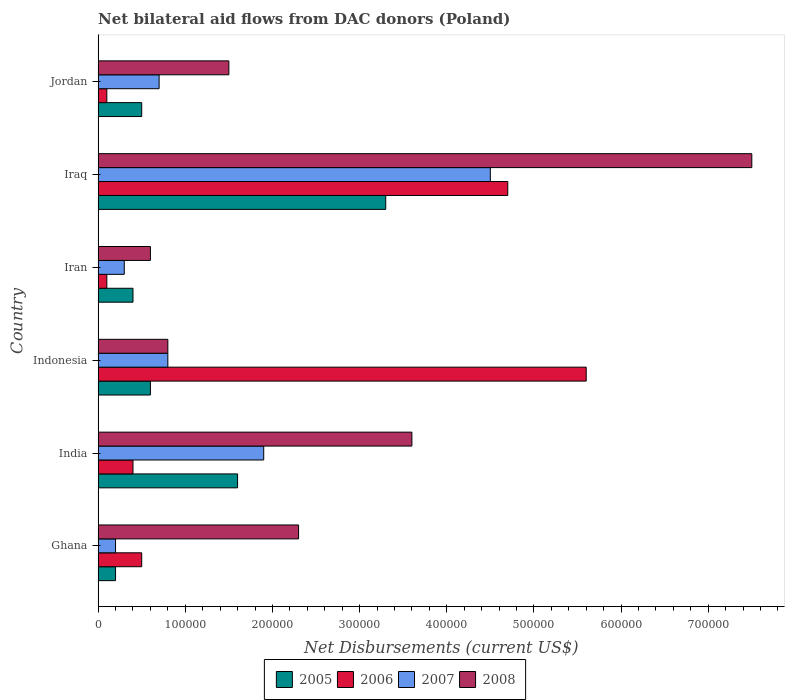How many groups of bars are there?
Provide a short and direct response. 6. Are the number of bars on each tick of the Y-axis equal?
Keep it short and to the point. Yes. What is the label of the 6th group of bars from the top?
Ensure brevity in your answer.  Ghana. Across all countries, what is the maximum net bilateral aid flows in 2006?
Offer a very short reply. 5.60e+05. Across all countries, what is the minimum net bilateral aid flows in 2008?
Your answer should be very brief. 6.00e+04. In which country was the net bilateral aid flows in 2008 maximum?
Your response must be concise. Iraq. In which country was the net bilateral aid flows in 2006 minimum?
Provide a short and direct response. Iran. What is the total net bilateral aid flows in 2006 in the graph?
Your answer should be compact. 1.14e+06. What is the difference between the net bilateral aid flows in 2005 in Indonesia and that in Iraq?
Give a very brief answer. -2.70e+05. What is the average net bilateral aid flows in 2006 per country?
Keep it short and to the point. 1.90e+05. What is the ratio of the net bilateral aid flows in 2007 in Indonesia to that in Iran?
Your answer should be very brief. 2.67. Is the net bilateral aid flows in 2006 in Iran less than that in Jordan?
Make the answer very short. No. Is the difference between the net bilateral aid flows in 2008 in Ghana and Iraq greater than the difference between the net bilateral aid flows in 2005 in Ghana and Iraq?
Provide a succinct answer. No. In how many countries, is the net bilateral aid flows in 2006 greater than the average net bilateral aid flows in 2006 taken over all countries?
Ensure brevity in your answer.  2. Is the sum of the net bilateral aid flows in 2008 in India and Indonesia greater than the maximum net bilateral aid flows in 2007 across all countries?
Give a very brief answer. No. Is it the case that in every country, the sum of the net bilateral aid flows in 2008 and net bilateral aid flows in 2007 is greater than the sum of net bilateral aid flows in 2006 and net bilateral aid flows in 2005?
Offer a very short reply. No. What does the 1st bar from the top in Jordan represents?
Provide a short and direct response. 2008. How many bars are there?
Your answer should be compact. 24. What is the difference between two consecutive major ticks on the X-axis?
Your answer should be very brief. 1.00e+05. Are the values on the major ticks of X-axis written in scientific E-notation?
Offer a terse response. No. Does the graph contain any zero values?
Make the answer very short. No. Does the graph contain grids?
Your answer should be very brief. No. What is the title of the graph?
Offer a terse response. Net bilateral aid flows from DAC donors (Poland). Does "1983" appear as one of the legend labels in the graph?
Ensure brevity in your answer.  No. What is the label or title of the X-axis?
Your answer should be very brief. Net Disbursements (current US$). What is the Net Disbursements (current US$) of 2007 in Ghana?
Your answer should be very brief. 2.00e+04. What is the Net Disbursements (current US$) of 2008 in Ghana?
Ensure brevity in your answer.  2.30e+05. What is the Net Disbursements (current US$) in 2005 in India?
Provide a short and direct response. 1.60e+05. What is the Net Disbursements (current US$) of 2008 in India?
Make the answer very short. 3.60e+05. What is the Net Disbursements (current US$) in 2006 in Indonesia?
Provide a short and direct response. 5.60e+05. What is the Net Disbursements (current US$) of 2008 in Indonesia?
Your response must be concise. 8.00e+04. What is the Net Disbursements (current US$) in 2006 in Iran?
Offer a terse response. 10000. What is the Net Disbursements (current US$) of 2008 in Iran?
Make the answer very short. 6.00e+04. What is the Net Disbursements (current US$) in 2008 in Iraq?
Provide a short and direct response. 7.50e+05. What is the Net Disbursements (current US$) of 2005 in Jordan?
Offer a very short reply. 5.00e+04. What is the Net Disbursements (current US$) in 2007 in Jordan?
Your response must be concise. 7.00e+04. What is the Net Disbursements (current US$) of 2008 in Jordan?
Give a very brief answer. 1.50e+05. Across all countries, what is the maximum Net Disbursements (current US$) of 2006?
Keep it short and to the point. 5.60e+05. Across all countries, what is the maximum Net Disbursements (current US$) of 2007?
Your answer should be compact. 4.50e+05. Across all countries, what is the maximum Net Disbursements (current US$) of 2008?
Provide a succinct answer. 7.50e+05. Across all countries, what is the minimum Net Disbursements (current US$) in 2005?
Make the answer very short. 2.00e+04. What is the total Net Disbursements (current US$) of 2006 in the graph?
Offer a very short reply. 1.14e+06. What is the total Net Disbursements (current US$) of 2007 in the graph?
Your answer should be compact. 8.40e+05. What is the total Net Disbursements (current US$) in 2008 in the graph?
Provide a succinct answer. 1.63e+06. What is the difference between the Net Disbursements (current US$) in 2005 in Ghana and that in India?
Provide a succinct answer. -1.40e+05. What is the difference between the Net Disbursements (current US$) in 2006 in Ghana and that in India?
Provide a succinct answer. 10000. What is the difference between the Net Disbursements (current US$) in 2006 in Ghana and that in Indonesia?
Ensure brevity in your answer.  -5.10e+05. What is the difference between the Net Disbursements (current US$) of 2008 in Ghana and that in Indonesia?
Make the answer very short. 1.50e+05. What is the difference between the Net Disbursements (current US$) of 2006 in Ghana and that in Iran?
Your answer should be compact. 4.00e+04. What is the difference between the Net Disbursements (current US$) of 2007 in Ghana and that in Iran?
Keep it short and to the point. -10000. What is the difference between the Net Disbursements (current US$) in 2008 in Ghana and that in Iran?
Keep it short and to the point. 1.70e+05. What is the difference between the Net Disbursements (current US$) in 2005 in Ghana and that in Iraq?
Your answer should be compact. -3.10e+05. What is the difference between the Net Disbursements (current US$) in 2006 in Ghana and that in Iraq?
Make the answer very short. -4.20e+05. What is the difference between the Net Disbursements (current US$) in 2007 in Ghana and that in Iraq?
Your answer should be very brief. -4.30e+05. What is the difference between the Net Disbursements (current US$) of 2008 in Ghana and that in Iraq?
Provide a short and direct response. -5.20e+05. What is the difference between the Net Disbursements (current US$) in 2007 in Ghana and that in Jordan?
Offer a very short reply. -5.00e+04. What is the difference between the Net Disbursements (current US$) in 2008 in Ghana and that in Jordan?
Provide a short and direct response. 8.00e+04. What is the difference between the Net Disbursements (current US$) in 2005 in India and that in Indonesia?
Offer a very short reply. 1.00e+05. What is the difference between the Net Disbursements (current US$) in 2006 in India and that in Indonesia?
Offer a terse response. -5.20e+05. What is the difference between the Net Disbursements (current US$) of 2007 in India and that in Indonesia?
Make the answer very short. 1.10e+05. What is the difference between the Net Disbursements (current US$) in 2008 in India and that in Indonesia?
Give a very brief answer. 2.80e+05. What is the difference between the Net Disbursements (current US$) of 2006 in India and that in Iran?
Offer a terse response. 3.00e+04. What is the difference between the Net Disbursements (current US$) in 2007 in India and that in Iran?
Ensure brevity in your answer.  1.60e+05. What is the difference between the Net Disbursements (current US$) of 2005 in India and that in Iraq?
Your answer should be compact. -1.70e+05. What is the difference between the Net Disbursements (current US$) in 2006 in India and that in Iraq?
Your response must be concise. -4.30e+05. What is the difference between the Net Disbursements (current US$) in 2008 in India and that in Iraq?
Your answer should be very brief. -3.90e+05. What is the difference between the Net Disbursements (current US$) in 2007 in India and that in Jordan?
Provide a succinct answer. 1.20e+05. What is the difference between the Net Disbursements (current US$) in 2008 in India and that in Jordan?
Your response must be concise. 2.10e+05. What is the difference between the Net Disbursements (current US$) in 2007 in Indonesia and that in Iran?
Offer a terse response. 5.00e+04. What is the difference between the Net Disbursements (current US$) of 2008 in Indonesia and that in Iran?
Provide a succinct answer. 2.00e+04. What is the difference between the Net Disbursements (current US$) of 2007 in Indonesia and that in Iraq?
Provide a succinct answer. -3.70e+05. What is the difference between the Net Disbursements (current US$) of 2008 in Indonesia and that in Iraq?
Keep it short and to the point. -6.70e+05. What is the difference between the Net Disbursements (current US$) of 2005 in Indonesia and that in Jordan?
Offer a terse response. 10000. What is the difference between the Net Disbursements (current US$) of 2007 in Indonesia and that in Jordan?
Your answer should be compact. 10000. What is the difference between the Net Disbursements (current US$) of 2006 in Iran and that in Iraq?
Keep it short and to the point. -4.60e+05. What is the difference between the Net Disbursements (current US$) in 2007 in Iran and that in Iraq?
Your response must be concise. -4.20e+05. What is the difference between the Net Disbursements (current US$) in 2008 in Iran and that in Iraq?
Give a very brief answer. -6.90e+05. What is the difference between the Net Disbursements (current US$) of 2005 in Iran and that in Jordan?
Provide a short and direct response. -10000. What is the difference between the Net Disbursements (current US$) of 2006 in Iran and that in Jordan?
Provide a short and direct response. 0. What is the difference between the Net Disbursements (current US$) in 2008 in Iran and that in Jordan?
Keep it short and to the point. -9.00e+04. What is the difference between the Net Disbursements (current US$) in 2005 in Iraq and that in Jordan?
Make the answer very short. 2.80e+05. What is the difference between the Net Disbursements (current US$) in 2008 in Iraq and that in Jordan?
Your response must be concise. 6.00e+05. What is the difference between the Net Disbursements (current US$) in 2006 in Ghana and the Net Disbursements (current US$) in 2008 in India?
Your answer should be very brief. -3.10e+05. What is the difference between the Net Disbursements (current US$) of 2007 in Ghana and the Net Disbursements (current US$) of 2008 in India?
Your response must be concise. -3.40e+05. What is the difference between the Net Disbursements (current US$) of 2005 in Ghana and the Net Disbursements (current US$) of 2006 in Indonesia?
Offer a very short reply. -5.40e+05. What is the difference between the Net Disbursements (current US$) of 2005 in Ghana and the Net Disbursements (current US$) of 2008 in Indonesia?
Offer a very short reply. -6.00e+04. What is the difference between the Net Disbursements (current US$) of 2006 in Ghana and the Net Disbursements (current US$) of 2007 in Indonesia?
Make the answer very short. -3.00e+04. What is the difference between the Net Disbursements (current US$) of 2006 in Ghana and the Net Disbursements (current US$) of 2008 in Indonesia?
Offer a terse response. -3.00e+04. What is the difference between the Net Disbursements (current US$) in 2007 in Ghana and the Net Disbursements (current US$) in 2008 in Indonesia?
Ensure brevity in your answer.  -6.00e+04. What is the difference between the Net Disbursements (current US$) of 2005 in Ghana and the Net Disbursements (current US$) of 2006 in Iran?
Give a very brief answer. 10000. What is the difference between the Net Disbursements (current US$) of 2005 in Ghana and the Net Disbursements (current US$) of 2007 in Iran?
Your response must be concise. -10000. What is the difference between the Net Disbursements (current US$) in 2005 in Ghana and the Net Disbursements (current US$) in 2008 in Iran?
Give a very brief answer. -4.00e+04. What is the difference between the Net Disbursements (current US$) of 2006 in Ghana and the Net Disbursements (current US$) of 2008 in Iran?
Ensure brevity in your answer.  -10000. What is the difference between the Net Disbursements (current US$) in 2007 in Ghana and the Net Disbursements (current US$) in 2008 in Iran?
Your response must be concise. -4.00e+04. What is the difference between the Net Disbursements (current US$) of 2005 in Ghana and the Net Disbursements (current US$) of 2006 in Iraq?
Make the answer very short. -4.50e+05. What is the difference between the Net Disbursements (current US$) in 2005 in Ghana and the Net Disbursements (current US$) in 2007 in Iraq?
Offer a very short reply. -4.30e+05. What is the difference between the Net Disbursements (current US$) in 2005 in Ghana and the Net Disbursements (current US$) in 2008 in Iraq?
Your answer should be compact. -7.30e+05. What is the difference between the Net Disbursements (current US$) in 2006 in Ghana and the Net Disbursements (current US$) in 2007 in Iraq?
Your answer should be very brief. -4.00e+05. What is the difference between the Net Disbursements (current US$) in 2006 in Ghana and the Net Disbursements (current US$) in 2008 in Iraq?
Make the answer very short. -7.00e+05. What is the difference between the Net Disbursements (current US$) in 2007 in Ghana and the Net Disbursements (current US$) in 2008 in Iraq?
Offer a terse response. -7.30e+05. What is the difference between the Net Disbursements (current US$) of 2005 in Ghana and the Net Disbursements (current US$) of 2006 in Jordan?
Keep it short and to the point. 10000. What is the difference between the Net Disbursements (current US$) in 2005 in Ghana and the Net Disbursements (current US$) in 2007 in Jordan?
Ensure brevity in your answer.  -5.00e+04. What is the difference between the Net Disbursements (current US$) in 2006 in Ghana and the Net Disbursements (current US$) in 2007 in Jordan?
Your response must be concise. -2.00e+04. What is the difference between the Net Disbursements (current US$) in 2007 in Ghana and the Net Disbursements (current US$) in 2008 in Jordan?
Make the answer very short. -1.30e+05. What is the difference between the Net Disbursements (current US$) of 2005 in India and the Net Disbursements (current US$) of 2006 in Indonesia?
Keep it short and to the point. -4.00e+05. What is the difference between the Net Disbursements (current US$) of 2005 in India and the Net Disbursements (current US$) of 2008 in Indonesia?
Your answer should be compact. 8.00e+04. What is the difference between the Net Disbursements (current US$) of 2006 in India and the Net Disbursements (current US$) of 2007 in Indonesia?
Your answer should be compact. -4.00e+04. What is the difference between the Net Disbursements (current US$) in 2006 in India and the Net Disbursements (current US$) in 2008 in Indonesia?
Offer a very short reply. -4.00e+04. What is the difference between the Net Disbursements (current US$) in 2005 in India and the Net Disbursements (current US$) in 2006 in Iran?
Provide a succinct answer. 1.50e+05. What is the difference between the Net Disbursements (current US$) in 2005 in India and the Net Disbursements (current US$) in 2007 in Iran?
Your response must be concise. 1.30e+05. What is the difference between the Net Disbursements (current US$) in 2005 in India and the Net Disbursements (current US$) in 2008 in Iran?
Keep it short and to the point. 1.00e+05. What is the difference between the Net Disbursements (current US$) in 2006 in India and the Net Disbursements (current US$) in 2008 in Iran?
Ensure brevity in your answer.  -2.00e+04. What is the difference between the Net Disbursements (current US$) in 2007 in India and the Net Disbursements (current US$) in 2008 in Iran?
Offer a very short reply. 1.30e+05. What is the difference between the Net Disbursements (current US$) in 2005 in India and the Net Disbursements (current US$) in 2006 in Iraq?
Provide a succinct answer. -3.10e+05. What is the difference between the Net Disbursements (current US$) of 2005 in India and the Net Disbursements (current US$) of 2007 in Iraq?
Provide a short and direct response. -2.90e+05. What is the difference between the Net Disbursements (current US$) of 2005 in India and the Net Disbursements (current US$) of 2008 in Iraq?
Provide a succinct answer. -5.90e+05. What is the difference between the Net Disbursements (current US$) of 2006 in India and the Net Disbursements (current US$) of 2007 in Iraq?
Provide a succinct answer. -4.10e+05. What is the difference between the Net Disbursements (current US$) in 2006 in India and the Net Disbursements (current US$) in 2008 in Iraq?
Provide a succinct answer. -7.10e+05. What is the difference between the Net Disbursements (current US$) in 2007 in India and the Net Disbursements (current US$) in 2008 in Iraq?
Ensure brevity in your answer.  -5.60e+05. What is the difference between the Net Disbursements (current US$) of 2005 in India and the Net Disbursements (current US$) of 2008 in Jordan?
Your answer should be very brief. 10000. What is the difference between the Net Disbursements (current US$) in 2006 in India and the Net Disbursements (current US$) in 2007 in Jordan?
Offer a very short reply. -3.00e+04. What is the difference between the Net Disbursements (current US$) of 2006 in India and the Net Disbursements (current US$) of 2008 in Jordan?
Offer a terse response. -1.10e+05. What is the difference between the Net Disbursements (current US$) in 2005 in Indonesia and the Net Disbursements (current US$) in 2006 in Iran?
Provide a short and direct response. 5.00e+04. What is the difference between the Net Disbursements (current US$) in 2006 in Indonesia and the Net Disbursements (current US$) in 2007 in Iran?
Your response must be concise. 5.30e+05. What is the difference between the Net Disbursements (current US$) of 2005 in Indonesia and the Net Disbursements (current US$) of 2006 in Iraq?
Your answer should be very brief. -4.10e+05. What is the difference between the Net Disbursements (current US$) in 2005 in Indonesia and the Net Disbursements (current US$) in 2007 in Iraq?
Offer a terse response. -3.90e+05. What is the difference between the Net Disbursements (current US$) of 2005 in Indonesia and the Net Disbursements (current US$) of 2008 in Iraq?
Offer a very short reply. -6.90e+05. What is the difference between the Net Disbursements (current US$) of 2006 in Indonesia and the Net Disbursements (current US$) of 2007 in Iraq?
Provide a short and direct response. 1.10e+05. What is the difference between the Net Disbursements (current US$) in 2006 in Indonesia and the Net Disbursements (current US$) in 2008 in Iraq?
Offer a very short reply. -1.90e+05. What is the difference between the Net Disbursements (current US$) in 2007 in Indonesia and the Net Disbursements (current US$) in 2008 in Iraq?
Your answer should be very brief. -6.70e+05. What is the difference between the Net Disbursements (current US$) of 2005 in Indonesia and the Net Disbursements (current US$) of 2006 in Jordan?
Ensure brevity in your answer.  5.00e+04. What is the difference between the Net Disbursements (current US$) in 2005 in Indonesia and the Net Disbursements (current US$) in 2007 in Jordan?
Offer a terse response. -10000. What is the difference between the Net Disbursements (current US$) of 2006 in Indonesia and the Net Disbursements (current US$) of 2007 in Jordan?
Make the answer very short. 4.90e+05. What is the difference between the Net Disbursements (current US$) of 2006 in Indonesia and the Net Disbursements (current US$) of 2008 in Jordan?
Provide a short and direct response. 4.10e+05. What is the difference between the Net Disbursements (current US$) in 2005 in Iran and the Net Disbursements (current US$) in 2006 in Iraq?
Offer a terse response. -4.30e+05. What is the difference between the Net Disbursements (current US$) of 2005 in Iran and the Net Disbursements (current US$) of 2007 in Iraq?
Your answer should be compact. -4.10e+05. What is the difference between the Net Disbursements (current US$) in 2005 in Iran and the Net Disbursements (current US$) in 2008 in Iraq?
Your answer should be very brief. -7.10e+05. What is the difference between the Net Disbursements (current US$) of 2006 in Iran and the Net Disbursements (current US$) of 2007 in Iraq?
Provide a succinct answer. -4.40e+05. What is the difference between the Net Disbursements (current US$) in 2006 in Iran and the Net Disbursements (current US$) in 2008 in Iraq?
Ensure brevity in your answer.  -7.40e+05. What is the difference between the Net Disbursements (current US$) of 2007 in Iran and the Net Disbursements (current US$) of 2008 in Iraq?
Your answer should be very brief. -7.20e+05. What is the difference between the Net Disbursements (current US$) in 2005 in Iran and the Net Disbursements (current US$) in 2006 in Jordan?
Provide a succinct answer. 3.00e+04. What is the difference between the Net Disbursements (current US$) in 2007 in Iran and the Net Disbursements (current US$) in 2008 in Jordan?
Your answer should be very brief. -1.20e+05. What is the average Net Disbursements (current US$) in 2005 per country?
Your response must be concise. 1.10e+05. What is the average Net Disbursements (current US$) in 2006 per country?
Ensure brevity in your answer.  1.90e+05. What is the average Net Disbursements (current US$) of 2007 per country?
Your answer should be very brief. 1.40e+05. What is the average Net Disbursements (current US$) of 2008 per country?
Give a very brief answer. 2.72e+05. What is the difference between the Net Disbursements (current US$) of 2005 and Net Disbursements (current US$) of 2006 in Ghana?
Keep it short and to the point. -3.00e+04. What is the difference between the Net Disbursements (current US$) in 2005 and Net Disbursements (current US$) in 2007 in Ghana?
Offer a very short reply. 0. What is the difference between the Net Disbursements (current US$) of 2005 and Net Disbursements (current US$) of 2008 in Ghana?
Offer a terse response. -2.10e+05. What is the difference between the Net Disbursements (current US$) in 2007 and Net Disbursements (current US$) in 2008 in Ghana?
Offer a terse response. -2.10e+05. What is the difference between the Net Disbursements (current US$) in 2005 and Net Disbursements (current US$) in 2007 in India?
Ensure brevity in your answer.  -3.00e+04. What is the difference between the Net Disbursements (current US$) in 2006 and Net Disbursements (current US$) in 2008 in India?
Provide a short and direct response. -3.20e+05. What is the difference between the Net Disbursements (current US$) in 2007 and Net Disbursements (current US$) in 2008 in India?
Offer a very short reply. -1.70e+05. What is the difference between the Net Disbursements (current US$) in 2005 and Net Disbursements (current US$) in 2006 in Indonesia?
Your response must be concise. -5.00e+05. What is the difference between the Net Disbursements (current US$) of 2005 and Net Disbursements (current US$) of 2008 in Indonesia?
Provide a short and direct response. -2.00e+04. What is the difference between the Net Disbursements (current US$) in 2005 and Net Disbursements (current US$) in 2007 in Iran?
Offer a terse response. 10000. What is the difference between the Net Disbursements (current US$) in 2006 and Net Disbursements (current US$) in 2007 in Iran?
Ensure brevity in your answer.  -2.00e+04. What is the difference between the Net Disbursements (current US$) of 2007 and Net Disbursements (current US$) of 2008 in Iran?
Your answer should be very brief. -3.00e+04. What is the difference between the Net Disbursements (current US$) of 2005 and Net Disbursements (current US$) of 2006 in Iraq?
Offer a terse response. -1.40e+05. What is the difference between the Net Disbursements (current US$) of 2005 and Net Disbursements (current US$) of 2007 in Iraq?
Keep it short and to the point. -1.20e+05. What is the difference between the Net Disbursements (current US$) of 2005 and Net Disbursements (current US$) of 2008 in Iraq?
Provide a succinct answer. -4.20e+05. What is the difference between the Net Disbursements (current US$) in 2006 and Net Disbursements (current US$) in 2007 in Iraq?
Provide a short and direct response. 2.00e+04. What is the difference between the Net Disbursements (current US$) of 2006 and Net Disbursements (current US$) of 2008 in Iraq?
Provide a short and direct response. -2.80e+05. What is the difference between the Net Disbursements (current US$) in 2005 and Net Disbursements (current US$) in 2006 in Jordan?
Provide a succinct answer. 4.00e+04. What is the difference between the Net Disbursements (current US$) of 2005 and Net Disbursements (current US$) of 2008 in Jordan?
Your response must be concise. -1.00e+05. What is the difference between the Net Disbursements (current US$) of 2006 and Net Disbursements (current US$) of 2007 in Jordan?
Make the answer very short. -6.00e+04. What is the difference between the Net Disbursements (current US$) of 2006 and Net Disbursements (current US$) of 2008 in Jordan?
Your answer should be very brief. -1.40e+05. What is the ratio of the Net Disbursements (current US$) in 2005 in Ghana to that in India?
Your response must be concise. 0.12. What is the ratio of the Net Disbursements (current US$) of 2007 in Ghana to that in India?
Your answer should be very brief. 0.11. What is the ratio of the Net Disbursements (current US$) of 2008 in Ghana to that in India?
Provide a succinct answer. 0.64. What is the ratio of the Net Disbursements (current US$) in 2006 in Ghana to that in Indonesia?
Keep it short and to the point. 0.09. What is the ratio of the Net Disbursements (current US$) of 2008 in Ghana to that in Indonesia?
Make the answer very short. 2.88. What is the ratio of the Net Disbursements (current US$) in 2005 in Ghana to that in Iran?
Your answer should be very brief. 0.5. What is the ratio of the Net Disbursements (current US$) in 2006 in Ghana to that in Iran?
Make the answer very short. 5. What is the ratio of the Net Disbursements (current US$) of 2008 in Ghana to that in Iran?
Your answer should be compact. 3.83. What is the ratio of the Net Disbursements (current US$) of 2005 in Ghana to that in Iraq?
Your response must be concise. 0.06. What is the ratio of the Net Disbursements (current US$) of 2006 in Ghana to that in Iraq?
Give a very brief answer. 0.11. What is the ratio of the Net Disbursements (current US$) of 2007 in Ghana to that in Iraq?
Keep it short and to the point. 0.04. What is the ratio of the Net Disbursements (current US$) of 2008 in Ghana to that in Iraq?
Provide a short and direct response. 0.31. What is the ratio of the Net Disbursements (current US$) of 2005 in Ghana to that in Jordan?
Give a very brief answer. 0.4. What is the ratio of the Net Disbursements (current US$) in 2007 in Ghana to that in Jordan?
Your response must be concise. 0.29. What is the ratio of the Net Disbursements (current US$) of 2008 in Ghana to that in Jordan?
Offer a very short reply. 1.53. What is the ratio of the Net Disbursements (current US$) of 2005 in India to that in Indonesia?
Ensure brevity in your answer.  2.67. What is the ratio of the Net Disbursements (current US$) in 2006 in India to that in Indonesia?
Keep it short and to the point. 0.07. What is the ratio of the Net Disbursements (current US$) of 2007 in India to that in Indonesia?
Your answer should be compact. 2.38. What is the ratio of the Net Disbursements (current US$) in 2008 in India to that in Indonesia?
Offer a terse response. 4.5. What is the ratio of the Net Disbursements (current US$) in 2007 in India to that in Iran?
Your response must be concise. 6.33. What is the ratio of the Net Disbursements (current US$) in 2008 in India to that in Iran?
Keep it short and to the point. 6. What is the ratio of the Net Disbursements (current US$) in 2005 in India to that in Iraq?
Offer a very short reply. 0.48. What is the ratio of the Net Disbursements (current US$) of 2006 in India to that in Iraq?
Give a very brief answer. 0.09. What is the ratio of the Net Disbursements (current US$) of 2007 in India to that in Iraq?
Your answer should be compact. 0.42. What is the ratio of the Net Disbursements (current US$) of 2008 in India to that in Iraq?
Offer a terse response. 0.48. What is the ratio of the Net Disbursements (current US$) of 2007 in India to that in Jordan?
Make the answer very short. 2.71. What is the ratio of the Net Disbursements (current US$) in 2007 in Indonesia to that in Iran?
Provide a short and direct response. 2.67. What is the ratio of the Net Disbursements (current US$) of 2005 in Indonesia to that in Iraq?
Your answer should be compact. 0.18. What is the ratio of the Net Disbursements (current US$) of 2006 in Indonesia to that in Iraq?
Your answer should be compact. 1.19. What is the ratio of the Net Disbursements (current US$) in 2007 in Indonesia to that in Iraq?
Offer a very short reply. 0.18. What is the ratio of the Net Disbursements (current US$) of 2008 in Indonesia to that in Iraq?
Ensure brevity in your answer.  0.11. What is the ratio of the Net Disbursements (current US$) of 2005 in Indonesia to that in Jordan?
Ensure brevity in your answer.  1.2. What is the ratio of the Net Disbursements (current US$) of 2006 in Indonesia to that in Jordan?
Your answer should be very brief. 56. What is the ratio of the Net Disbursements (current US$) in 2008 in Indonesia to that in Jordan?
Make the answer very short. 0.53. What is the ratio of the Net Disbursements (current US$) of 2005 in Iran to that in Iraq?
Keep it short and to the point. 0.12. What is the ratio of the Net Disbursements (current US$) in 2006 in Iran to that in Iraq?
Offer a very short reply. 0.02. What is the ratio of the Net Disbursements (current US$) in 2007 in Iran to that in Iraq?
Keep it short and to the point. 0.07. What is the ratio of the Net Disbursements (current US$) of 2008 in Iran to that in Iraq?
Ensure brevity in your answer.  0.08. What is the ratio of the Net Disbursements (current US$) of 2006 in Iran to that in Jordan?
Your response must be concise. 1. What is the ratio of the Net Disbursements (current US$) of 2007 in Iran to that in Jordan?
Provide a short and direct response. 0.43. What is the ratio of the Net Disbursements (current US$) in 2008 in Iran to that in Jordan?
Make the answer very short. 0.4. What is the ratio of the Net Disbursements (current US$) in 2005 in Iraq to that in Jordan?
Provide a succinct answer. 6.6. What is the ratio of the Net Disbursements (current US$) in 2006 in Iraq to that in Jordan?
Provide a short and direct response. 47. What is the ratio of the Net Disbursements (current US$) of 2007 in Iraq to that in Jordan?
Your response must be concise. 6.43. What is the difference between the highest and the second highest Net Disbursements (current US$) of 2005?
Keep it short and to the point. 1.70e+05. What is the difference between the highest and the second highest Net Disbursements (current US$) of 2006?
Your answer should be compact. 9.00e+04. What is the difference between the highest and the lowest Net Disbursements (current US$) of 2005?
Provide a short and direct response. 3.10e+05. What is the difference between the highest and the lowest Net Disbursements (current US$) of 2008?
Ensure brevity in your answer.  6.90e+05. 